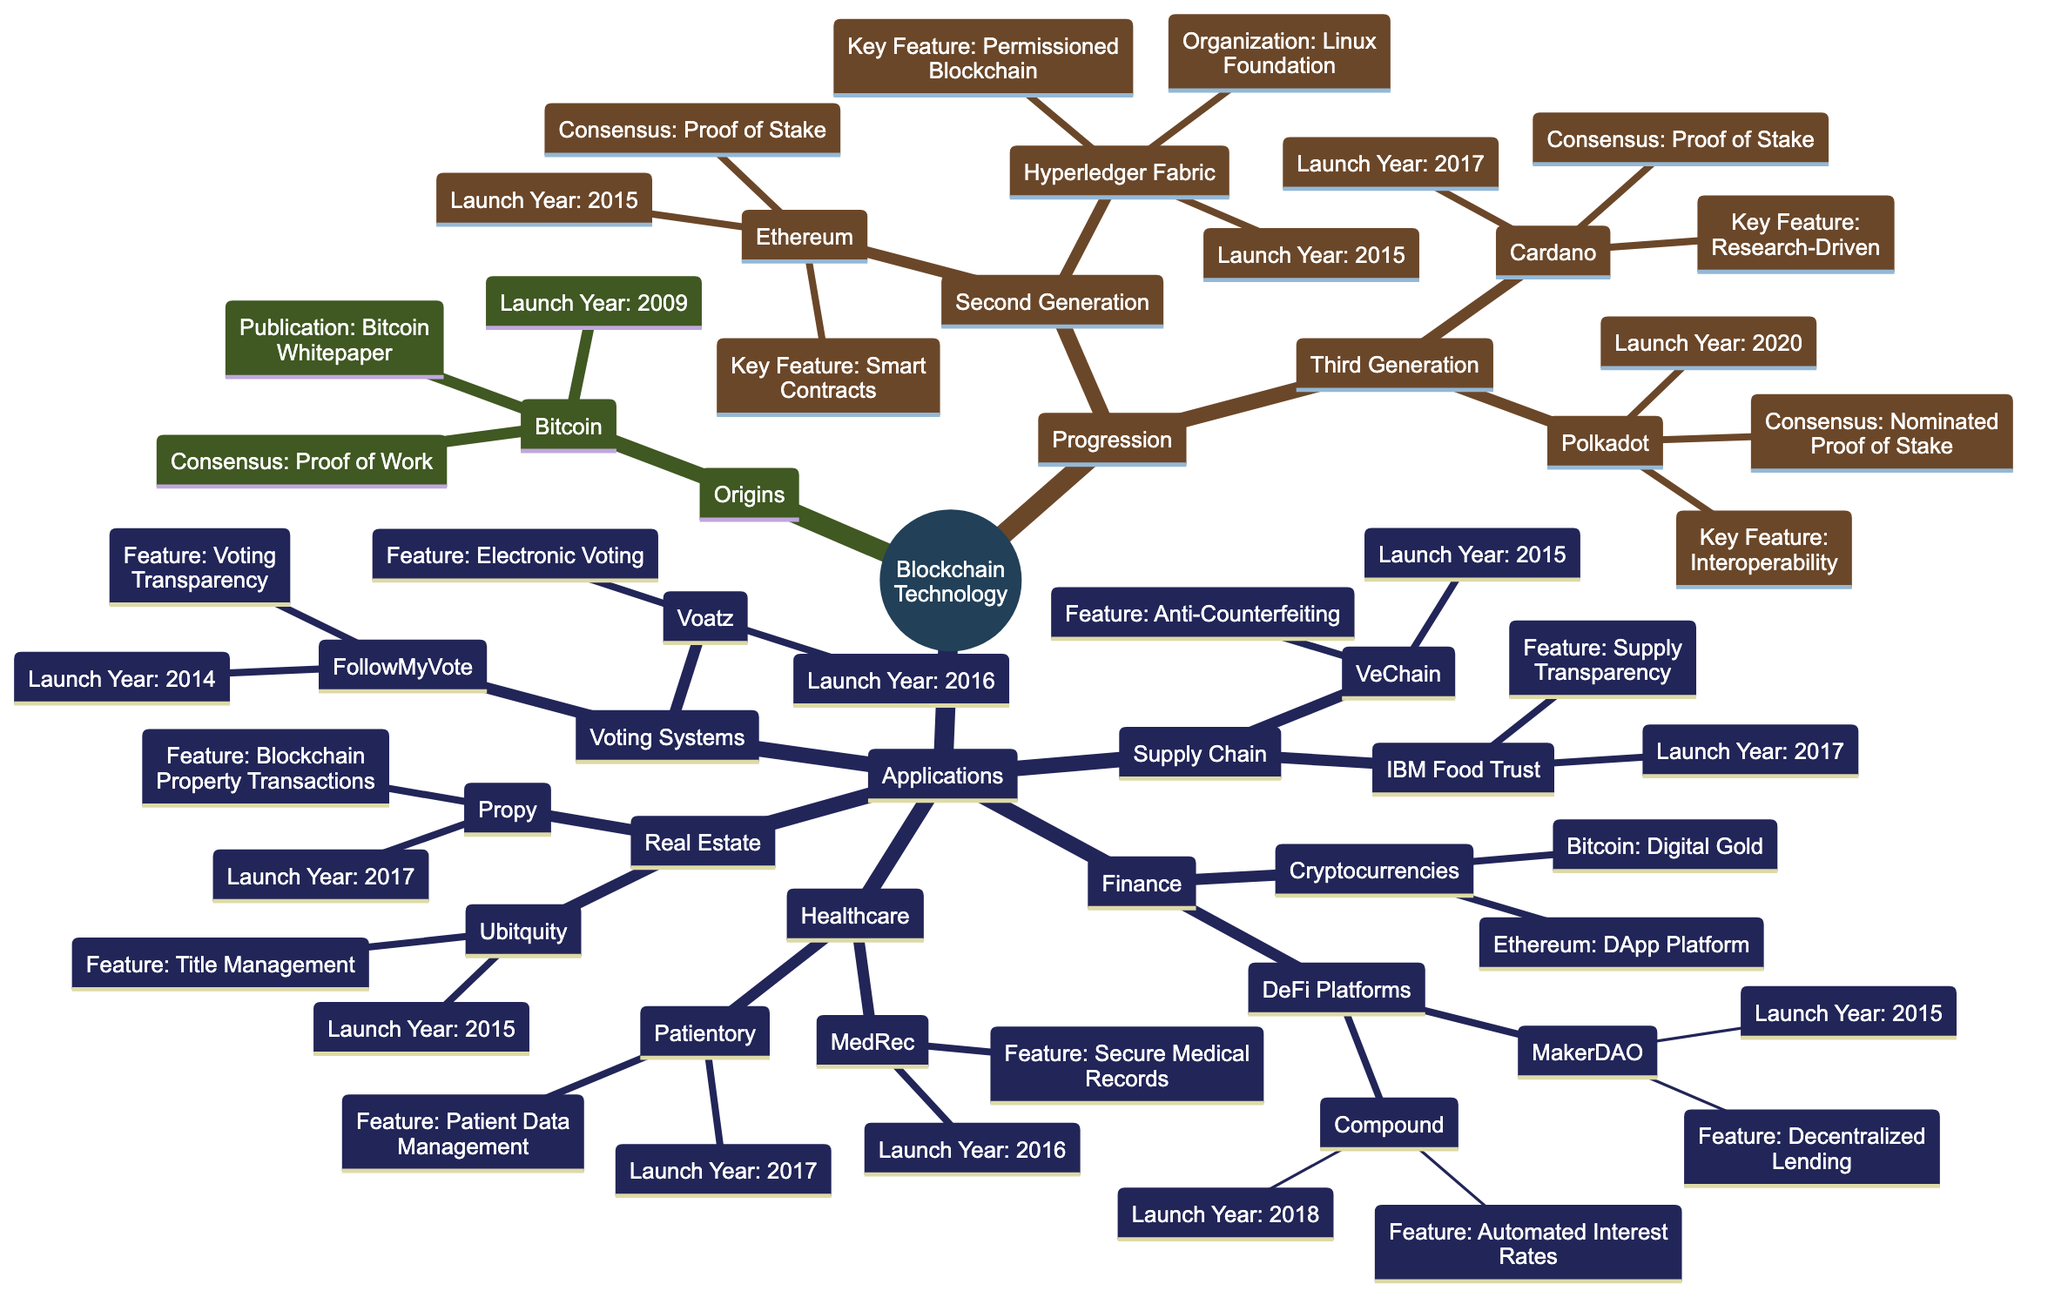What's the launch year of Bitcoin? The diagram states that Bitcoin was launched in the year 2009, which is directly associated with the node for Bitcoin under the Origins section.
Answer: 2009 What is the key feature of Ethereum? The node for Ethereum displays that its key feature is "Smart Contracts," which is the information provided in the corresponding section about Ethereum in the second generation of blockchains.
Answer: Smart Contracts How many applications are listed under Finance? By counting the nodes under the Finance section in the Applications part of the diagram, there are two main categories: "DeFi Platforms" and "Cryptocurrencies," which contain a total of four distinct applications.
Answer: 4 Which organization is responsible for Hyperledger Fabric? The diagram shows that Hyperledger Fabric is under the second generation of blockchain technologies and it specifies that it is organized by the "Linux Foundation."
Answer: Linux Foundation What consensus mechanism does Cardano use? The diagram indicates that Cardano, under the third generation of blockchains, uses the "Proof of Stake" consensus mechanism, as specifically noted in its description.
Answer: Proof of Stake Which industry has IBM Food Trust as an application? The diagram clearly shows that IBM Food Trust is listed under the Supply Chain section of Applications, associating this application directly with the Supply Chain industry.
Answer: Supply Chain In which year was Compound launched? The diagram indicates that Compound, listed under the DeFi Platforms in Finance, has a launch year of 2018, as documented in its node.
Answer: 2018 What is a notable use case of Voatz? According to the diagram, Voatz is linked to the notable use case of "West Virginia 2018 Midterm Elections," which is specified in its description under the Voting Systems section.
Answer: West Virginia 2018 Midterm Elections How does the key feature of Propy relate to Real Estate? The diagram describes Propy, which is categorized under Real Estate, and states that its key feature is "Blockchain-Based Property Transactions," connecting its functionality directly to the Real Estate industry.
Answer: Blockchain-Based Property Transactions 